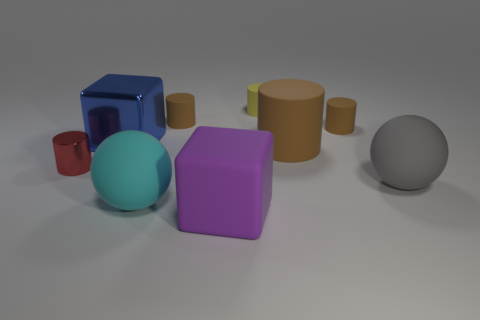Is there any other thing that is the same color as the small shiny cylinder?
Keep it short and to the point. No. There is a yellow matte object that is the same size as the red cylinder; what shape is it?
Make the answer very short. Cylinder. How many other things are the same color as the large rubber cylinder?
Offer a terse response. 2. How many small red things are there?
Offer a terse response. 1. How many things are in front of the big brown matte object and behind the large purple rubber object?
Your answer should be compact. 3. What is the red thing made of?
Make the answer very short. Metal. Are there any cyan metal cubes?
Your response must be concise. No. There is a tiny thing that is left of the large blue cube; what color is it?
Give a very brief answer. Red. There is a cube behind the ball that is behind the cyan thing; how many small red cylinders are on the left side of it?
Offer a very short reply. 1. There is a thing that is both in front of the big gray rubber ball and behind the big rubber block; what is its material?
Your answer should be very brief. Rubber. 